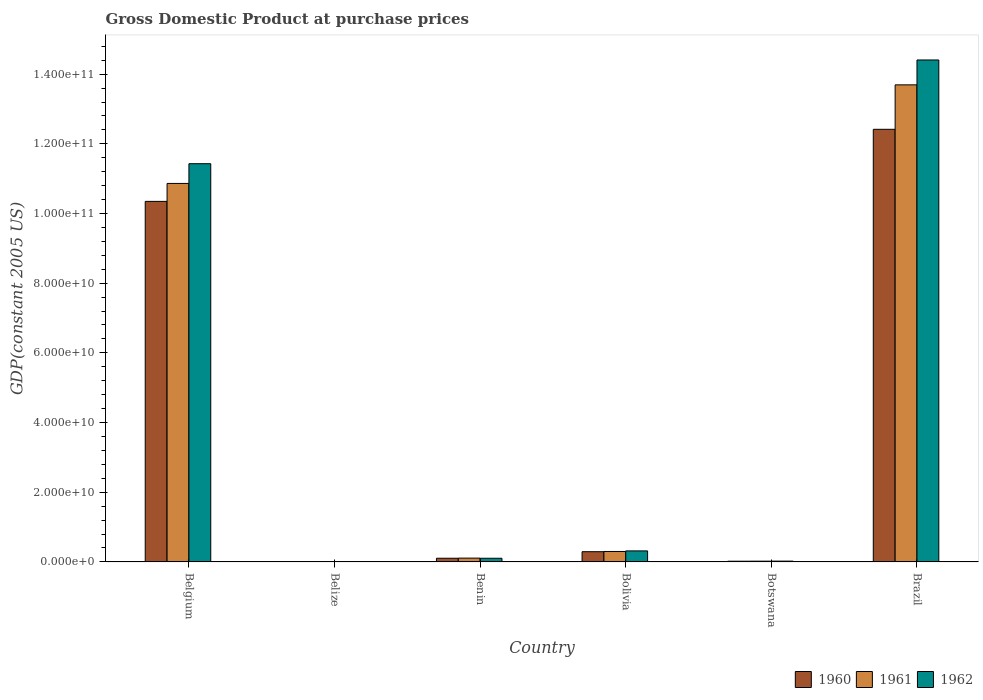How many groups of bars are there?
Keep it short and to the point. 6. How many bars are there on the 5th tick from the left?
Offer a terse response. 3. What is the GDP at purchase prices in 1962 in Botswana?
Ensure brevity in your answer.  2.26e+08. Across all countries, what is the maximum GDP at purchase prices in 1961?
Give a very brief answer. 1.37e+11. Across all countries, what is the minimum GDP at purchase prices in 1961?
Your answer should be very brief. 9.38e+07. In which country was the GDP at purchase prices in 1960 maximum?
Your answer should be compact. Brazil. In which country was the GDP at purchase prices in 1960 minimum?
Your answer should be compact. Belize. What is the total GDP at purchase prices in 1961 in the graph?
Keep it short and to the point. 2.50e+11. What is the difference between the GDP at purchase prices in 1961 in Botswana and that in Brazil?
Your response must be concise. -1.37e+11. What is the difference between the GDP at purchase prices in 1961 in Belgium and the GDP at purchase prices in 1960 in Botswana?
Your answer should be very brief. 1.08e+11. What is the average GDP at purchase prices in 1961 per country?
Your answer should be compact. 4.17e+1. What is the difference between the GDP at purchase prices of/in 1961 and GDP at purchase prices of/in 1960 in Belize?
Make the answer very short. 4.38e+06. What is the ratio of the GDP at purchase prices in 1961 in Belize to that in Botswana?
Give a very brief answer. 0.44. What is the difference between the highest and the second highest GDP at purchase prices in 1962?
Offer a very short reply. 1.11e+11. What is the difference between the highest and the lowest GDP at purchase prices in 1960?
Offer a very short reply. 1.24e+11. Is the sum of the GDP at purchase prices in 1960 in Botswana and Brazil greater than the maximum GDP at purchase prices in 1962 across all countries?
Your answer should be compact. No. What does the 3rd bar from the left in Brazil represents?
Ensure brevity in your answer.  1962. Are all the bars in the graph horizontal?
Give a very brief answer. No. What is the difference between two consecutive major ticks on the Y-axis?
Keep it short and to the point. 2.00e+1. What is the title of the graph?
Your answer should be very brief. Gross Domestic Product at purchase prices. What is the label or title of the X-axis?
Ensure brevity in your answer.  Country. What is the label or title of the Y-axis?
Your answer should be very brief. GDP(constant 2005 US). What is the GDP(constant 2005 US) of 1960 in Belgium?
Give a very brief answer. 1.03e+11. What is the GDP(constant 2005 US) of 1961 in Belgium?
Ensure brevity in your answer.  1.09e+11. What is the GDP(constant 2005 US) of 1962 in Belgium?
Offer a very short reply. 1.14e+11. What is the GDP(constant 2005 US) in 1960 in Belize?
Your answer should be very brief. 8.94e+07. What is the GDP(constant 2005 US) of 1961 in Belize?
Your answer should be compact. 9.38e+07. What is the GDP(constant 2005 US) in 1962 in Belize?
Your answer should be very brief. 9.84e+07. What is the GDP(constant 2005 US) in 1960 in Benin?
Provide a succinct answer. 1.05e+09. What is the GDP(constant 2005 US) of 1961 in Benin?
Your answer should be very brief. 1.09e+09. What is the GDP(constant 2005 US) of 1962 in Benin?
Offer a terse response. 1.05e+09. What is the GDP(constant 2005 US) of 1960 in Bolivia?
Make the answer very short. 2.93e+09. What is the GDP(constant 2005 US) in 1961 in Bolivia?
Give a very brief answer. 2.99e+09. What is the GDP(constant 2005 US) in 1962 in Bolivia?
Your answer should be compact. 3.16e+09. What is the GDP(constant 2005 US) in 1960 in Botswana?
Provide a short and direct response. 1.99e+08. What is the GDP(constant 2005 US) in 1961 in Botswana?
Make the answer very short. 2.12e+08. What is the GDP(constant 2005 US) of 1962 in Botswana?
Provide a succinct answer. 2.26e+08. What is the GDP(constant 2005 US) of 1960 in Brazil?
Make the answer very short. 1.24e+11. What is the GDP(constant 2005 US) in 1961 in Brazil?
Provide a succinct answer. 1.37e+11. What is the GDP(constant 2005 US) of 1962 in Brazil?
Offer a very short reply. 1.44e+11. Across all countries, what is the maximum GDP(constant 2005 US) of 1960?
Offer a terse response. 1.24e+11. Across all countries, what is the maximum GDP(constant 2005 US) in 1961?
Provide a short and direct response. 1.37e+11. Across all countries, what is the maximum GDP(constant 2005 US) of 1962?
Give a very brief answer. 1.44e+11. Across all countries, what is the minimum GDP(constant 2005 US) of 1960?
Your answer should be very brief. 8.94e+07. Across all countries, what is the minimum GDP(constant 2005 US) in 1961?
Offer a terse response. 9.38e+07. Across all countries, what is the minimum GDP(constant 2005 US) of 1962?
Your response must be concise. 9.84e+07. What is the total GDP(constant 2005 US) of 1960 in the graph?
Your response must be concise. 2.32e+11. What is the total GDP(constant 2005 US) in 1961 in the graph?
Ensure brevity in your answer.  2.50e+11. What is the total GDP(constant 2005 US) in 1962 in the graph?
Offer a terse response. 2.63e+11. What is the difference between the GDP(constant 2005 US) in 1960 in Belgium and that in Belize?
Keep it short and to the point. 1.03e+11. What is the difference between the GDP(constant 2005 US) of 1961 in Belgium and that in Belize?
Offer a very short reply. 1.09e+11. What is the difference between the GDP(constant 2005 US) in 1962 in Belgium and that in Belize?
Your answer should be compact. 1.14e+11. What is the difference between the GDP(constant 2005 US) in 1960 in Belgium and that in Benin?
Keep it short and to the point. 1.02e+11. What is the difference between the GDP(constant 2005 US) of 1961 in Belgium and that in Benin?
Provide a short and direct response. 1.08e+11. What is the difference between the GDP(constant 2005 US) in 1962 in Belgium and that in Benin?
Your answer should be very brief. 1.13e+11. What is the difference between the GDP(constant 2005 US) of 1960 in Belgium and that in Bolivia?
Ensure brevity in your answer.  1.01e+11. What is the difference between the GDP(constant 2005 US) of 1961 in Belgium and that in Bolivia?
Make the answer very short. 1.06e+11. What is the difference between the GDP(constant 2005 US) in 1962 in Belgium and that in Bolivia?
Ensure brevity in your answer.  1.11e+11. What is the difference between the GDP(constant 2005 US) of 1960 in Belgium and that in Botswana?
Offer a terse response. 1.03e+11. What is the difference between the GDP(constant 2005 US) in 1961 in Belgium and that in Botswana?
Ensure brevity in your answer.  1.08e+11. What is the difference between the GDP(constant 2005 US) in 1962 in Belgium and that in Botswana?
Ensure brevity in your answer.  1.14e+11. What is the difference between the GDP(constant 2005 US) in 1960 in Belgium and that in Brazil?
Your answer should be compact. -2.07e+1. What is the difference between the GDP(constant 2005 US) in 1961 in Belgium and that in Brazil?
Give a very brief answer. -2.83e+1. What is the difference between the GDP(constant 2005 US) in 1962 in Belgium and that in Brazil?
Offer a very short reply. -2.98e+1. What is the difference between the GDP(constant 2005 US) of 1960 in Belize and that in Benin?
Your answer should be compact. -9.64e+08. What is the difference between the GDP(constant 2005 US) in 1961 in Belize and that in Benin?
Provide a short and direct response. -9.92e+08. What is the difference between the GDP(constant 2005 US) of 1962 in Belize and that in Benin?
Ensure brevity in your answer.  -9.50e+08. What is the difference between the GDP(constant 2005 US) of 1960 in Belize and that in Bolivia?
Ensure brevity in your answer.  -2.84e+09. What is the difference between the GDP(constant 2005 US) of 1961 in Belize and that in Bolivia?
Your response must be concise. -2.90e+09. What is the difference between the GDP(constant 2005 US) in 1962 in Belize and that in Bolivia?
Your answer should be very brief. -3.06e+09. What is the difference between the GDP(constant 2005 US) in 1960 in Belize and that in Botswana?
Your response must be concise. -1.10e+08. What is the difference between the GDP(constant 2005 US) of 1961 in Belize and that in Botswana?
Give a very brief answer. -1.18e+08. What is the difference between the GDP(constant 2005 US) in 1962 in Belize and that in Botswana?
Keep it short and to the point. -1.27e+08. What is the difference between the GDP(constant 2005 US) in 1960 in Belize and that in Brazil?
Offer a very short reply. -1.24e+11. What is the difference between the GDP(constant 2005 US) in 1961 in Belize and that in Brazil?
Provide a succinct answer. -1.37e+11. What is the difference between the GDP(constant 2005 US) of 1962 in Belize and that in Brazil?
Your answer should be compact. -1.44e+11. What is the difference between the GDP(constant 2005 US) of 1960 in Benin and that in Bolivia?
Provide a succinct answer. -1.88e+09. What is the difference between the GDP(constant 2005 US) in 1961 in Benin and that in Bolivia?
Give a very brief answer. -1.91e+09. What is the difference between the GDP(constant 2005 US) in 1962 in Benin and that in Bolivia?
Keep it short and to the point. -2.11e+09. What is the difference between the GDP(constant 2005 US) in 1960 in Benin and that in Botswana?
Give a very brief answer. 8.54e+08. What is the difference between the GDP(constant 2005 US) of 1961 in Benin and that in Botswana?
Ensure brevity in your answer.  8.74e+08. What is the difference between the GDP(constant 2005 US) in 1962 in Benin and that in Botswana?
Offer a terse response. 8.23e+08. What is the difference between the GDP(constant 2005 US) of 1960 in Benin and that in Brazil?
Ensure brevity in your answer.  -1.23e+11. What is the difference between the GDP(constant 2005 US) in 1961 in Benin and that in Brazil?
Offer a very short reply. -1.36e+11. What is the difference between the GDP(constant 2005 US) of 1962 in Benin and that in Brazil?
Your response must be concise. -1.43e+11. What is the difference between the GDP(constant 2005 US) in 1960 in Bolivia and that in Botswana?
Your answer should be very brief. 2.73e+09. What is the difference between the GDP(constant 2005 US) of 1961 in Bolivia and that in Botswana?
Ensure brevity in your answer.  2.78e+09. What is the difference between the GDP(constant 2005 US) of 1962 in Bolivia and that in Botswana?
Provide a succinct answer. 2.93e+09. What is the difference between the GDP(constant 2005 US) of 1960 in Bolivia and that in Brazil?
Give a very brief answer. -1.21e+11. What is the difference between the GDP(constant 2005 US) in 1961 in Bolivia and that in Brazil?
Your answer should be compact. -1.34e+11. What is the difference between the GDP(constant 2005 US) of 1962 in Bolivia and that in Brazil?
Give a very brief answer. -1.41e+11. What is the difference between the GDP(constant 2005 US) of 1960 in Botswana and that in Brazil?
Offer a terse response. -1.24e+11. What is the difference between the GDP(constant 2005 US) of 1961 in Botswana and that in Brazil?
Your answer should be very brief. -1.37e+11. What is the difference between the GDP(constant 2005 US) in 1962 in Botswana and that in Brazil?
Give a very brief answer. -1.44e+11. What is the difference between the GDP(constant 2005 US) in 1960 in Belgium and the GDP(constant 2005 US) in 1961 in Belize?
Keep it short and to the point. 1.03e+11. What is the difference between the GDP(constant 2005 US) in 1960 in Belgium and the GDP(constant 2005 US) in 1962 in Belize?
Provide a succinct answer. 1.03e+11. What is the difference between the GDP(constant 2005 US) of 1961 in Belgium and the GDP(constant 2005 US) of 1962 in Belize?
Keep it short and to the point. 1.09e+11. What is the difference between the GDP(constant 2005 US) of 1960 in Belgium and the GDP(constant 2005 US) of 1961 in Benin?
Give a very brief answer. 1.02e+11. What is the difference between the GDP(constant 2005 US) of 1960 in Belgium and the GDP(constant 2005 US) of 1962 in Benin?
Your answer should be very brief. 1.02e+11. What is the difference between the GDP(constant 2005 US) in 1961 in Belgium and the GDP(constant 2005 US) in 1962 in Benin?
Your answer should be very brief. 1.08e+11. What is the difference between the GDP(constant 2005 US) in 1960 in Belgium and the GDP(constant 2005 US) in 1961 in Bolivia?
Offer a very short reply. 1.00e+11. What is the difference between the GDP(constant 2005 US) in 1960 in Belgium and the GDP(constant 2005 US) in 1962 in Bolivia?
Make the answer very short. 1.00e+11. What is the difference between the GDP(constant 2005 US) in 1961 in Belgium and the GDP(constant 2005 US) in 1962 in Bolivia?
Give a very brief answer. 1.05e+11. What is the difference between the GDP(constant 2005 US) in 1960 in Belgium and the GDP(constant 2005 US) in 1961 in Botswana?
Offer a terse response. 1.03e+11. What is the difference between the GDP(constant 2005 US) in 1960 in Belgium and the GDP(constant 2005 US) in 1962 in Botswana?
Ensure brevity in your answer.  1.03e+11. What is the difference between the GDP(constant 2005 US) in 1961 in Belgium and the GDP(constant 2005 US) in 1962 in Botswana?
Provide a succinct answer. 1.08e+11. What is the difference between the GDP(constant 2005 US) of 1960 in Belgium and the GDP(constant 2005 US) of 1961 in Brazil?
Your answer should be very brief. -3.34e+1. What is the difference between the GDP(constant 2005 US) in 1960 in Belgium and the GDP(constant 2005 US) in 1962 in Brazil?
Offer a terse response. -4.06e+1. What is the difference between the GDP(constant 2005 US) in 1961 in Belgium and the GDP(constant 2005 US) in 1962 in Brazil?
Your answer should be compact. -3.54e+1. What is the difference between the GDP(constant 2005 US) of 1960 in Belize and the GDP(constant 2005 US) of 1961 in Benin?
Your response must be concise. -9.97e+08. What is the difference between the GDP(constant 2005 US) in 1960 in Belize and the GDP(constant 2005 US) in 1962 in Benin?
Ensure brevity in your answer.  -9.59e+08. What is the difference between the GDP(constant 2005 US) of 1961 in Belize and the GDP(constant 2005 US) of 1962 in Benin?
Make the answer very short. -9.55e+08. What is the difference between the GDP(constant 2005 US) in 1960 in Belize and the GDP(constant 2005 US) in 1961 in Bolivia?
Provide a succinct answer. -2.90e+09. What is the difference between the GDP(constant 2005 US) of 1960 in Belize and the GDP(constant 2005 US) of 1962 in Bolivia?
Provide a short and direct response. -3.07e+09. What is the difference between the GDP(constant 2005 US) in 1961 in Belize and the GDP(constant 2005 US) in 1962 in Bolivia?
Make the answer very short. -3.07e+09. What is the difference between the GDP(constant 2005 US) in 1960 in Belize and the GDP(constant 2005 US) in 1961 in Botswana?
Provide a succinct answer. -1.22e+08. What is the difference between the GDP(constant 2005 US) of 1960 in Belize and the GDP(constant 2005 US) of 1962 in Botswana?
Your response must be concise. -1.36e+08. What is the difference between the GDP(constant 2005 US) of 1961 in Belize and the GDP(constant 2005 US) of 1962 in Botswana?
Your answer should be very brief. -1.32e+08. What is the difference between the GDP(constant 2005 US) of 1960 in Belize and the GDP(constant 2005 US) of 1961 in Brazil?
Provide a short and direct response. -1.37e+11. What is the difference between the GDP(constant 2005 US) of 1960 in Belize and the GDP(constant 2005 US) of 1962 in Brazil?
Provide a succinct answer. -1.44e+11. What is the difference between the GDP(constant 2005 US) of 1961 in Belize and the GDP(constant 2005 US) of 1962 in Brazil?
Your answer should be very brief. -1.44e+11. What is the difference between the GDP(constant 2005 US) of 1960 in Benin and the GDP(constant 2005 US) of 1961 in Bolivia?
Offer a very short reply. -1.94e+09. What is the difference between the GDP(constant 2005 US) in 1960 in Benin and the GDP(constant 2005 US) in 1962 in Bolivia?
Keep it short and to the point. -2.11e+09. What is the difference between the GDP(constant 2005 US) of 1961 in Benin and the GDP(constant 2005 US) of 1962 in Bolivia?
Provide a short and direct response. -2.07e+09. What is the difference between the GDP(constant 2005 US) of 1960 in Benin and the GDP(constant 2005 US) of 1961 in Botswana?
Keep it short and to the point. 8.41e+08. What is the difference between the GDP(constant 2005 US) of 1960 in Benin and the GDP(constant 2005 US) of 1962 in Botswana?
Make the answer very short. 8.27e+08. What is the difference between the GDP(constant 2005 US) in 1961 in Benin and the GDP(constant 2005 US) in 1962 in Botswana?
Give a very brief answer. 8.60e+08. What is the difference between the GDP(constant 2005 US) in 1960 in Benin and the GDP(constant 2005 US) in 1961 in Brazil?
Keep it short and to the point. -1.36e+11. What is the difference between the GDP(constant 2005 US) in 1960 in Benin and the GDP(constant 2005 US) in 1962 in Brazil?
Ensure brevity in your answer.  -1.43e+11. What is the difference between the GDP(constant 2005 US) of 1961 in Benin and the GDP(constant 2005 US) of 1962 in Brazil?
Provide a short and direct response. -1.43e+11. What is the difference between the GDP(constant 2005 US) in 1960 in Bolivia and the GDP(constant 2005 US) in 1961 in Botswana?
Your answer should be compact. 2.72e+09. What is the difference between the GDP(constant 2005 US) of 1960 in Bolivia and the GDP(constant 2005 US) of 1962 in Botswana?
Ensure brevity in your answer.  2.71e+09. What is the difference between the GDP(constant 2005 US) in 1961 in Bolivia and the GDP(constant 2005 US) in 1962 in Botswana?
Ensure brevity in your answer.  2.77e+09. What is the difference between the GDP(constant 2005 US) in 1960 in Bolivia and the GDP(constant 2005 US) in 1961 in Brazil?
Make the answer very short. -1.34e+11. What is the difference between the GDP(constant 2005 US) of 1960 in Bolivia and the GDP(constant 2005 US) of 1962 in Brazil?
Ensure brevity in your answer.  -1.41e+11. What is the difference between the GDP(constant 2005 US) in 1961 in Bolivia and the GDP(constant 2005 US) in 1962 in Brazil?
Your response must be concise. -1.41e+11. What is the difference between the GDP(constant 2005 US) of 1960 in Botswana and the GDP(constant 2005 US) of 1961 in Brazil?
Offer a very short reply. -1.37e+11. What is the difference between the GDP(constant 2005 US) in 1960 in Botswana and the GDP(constant 2005 US) in 1962 in Brazil?
Offer a very short reply. -1.44e+11. What is the difference between the GDP(constant 2005 US) in 1961 in Botswana and the GDP(constant 2005 US) in 1962 in Brazil?
Make the answer very short. -1.44e+11. What is the average GDP(constant 2005 US) of 1960 per country?
Provide a succinct answer. 3.87e+1. What is the average GDP(constant 2005 US) of 1961 per country?
Provide a short and direct response. 4.17e+1. What is the average GDP(constant 2005 US) of 1962 per country?
Provide a short and direct response. 4.38e+1. What is the difference between the GDP(constant 2005 US) of 1960 and GDP(constant 2005 US) of 1961 in Belgium?
Give a very brief answer. -5.15e+09. What is the difference between the GDP(constant 2005 US) in 1960 and GDP(constant 2005 US) in 1962 in Belgium?
Give a very brief answer. -1.08e+1. What is the difference between the GDP(constant 2005 US) of 1961 and GDP(constant 2005 US) of 1962 in Belgium?
Offer a very short reply. -5.66e+09. What is the difference between the GDP(constant 2005 US) of 1960 and GDP(constant 2005 US) of 1961 in Belize?
Give a very brief answer. -4.38e+06. What is the difference between the GDP(constant 2005 US) of 1960 and GDP(constant 2005 US) of 1962 in Belize?
Offer a very short reply. -8.97e+06. What is the difference between the GDP(constant 2005 US) of 1961 and GDP(constant 2005 US) of 1962 in Belize?
Your response must be concise. -4.59e+06. What is the difference between the GDP(constant 2005 US) of 1960 and GDP(constant 2005 US) of 1961 in Benin?
Give a very brief answer. -3.31e+07. What is the difference between the GDP(constant 2005 US) in 1960 and GDP(constant 2005 US) in 1962 in Benin?
Offer a terse response. 4.14e+06. What is the difference between the GDP(constant 2005 US) of 1961 and GDP(constant 2005 US) of 1962 in Benin?
Offer a terse response. 3.72e+07. What is the difference between the GDP(constant 2005 US) in 1960 and GDP(constant 2005 US) in 1961 in Bolivia?
Offer a very short reply. -6.10e+07. What is the difference between the GDP(constant 2005 US) in 1960 and GDP(constant 2005 US) in 1962 in Bolivia?
Make the answer very short. -2.28e+08. What is the difference between the GDP(constant 2005 US) in 1961 and GDP(constant 2005 US) in 1962 in Bolivia?
Provide a succinct answer. -1.67e+08. What is the difference between the GDP(constant 2005 US) in 1960 and GDP(constant 2005 US) in 1961 in Botswana?
Keep it short and to the point. -1.26e+07. What is the difference between the GDP(constant 2005 US) in 1960 and GDP(constant 2005 US) in 1962 in Botswana?
Your response must be concise. -2.67e+07. What is the difference between the GDP(constant 2005 US) in 1961 and GDP(constant 2005 US) in 1962 in Botswana?
Your answer should be very brief. -1.41e+07. What is the difference between the GDP(constant 2005 US) of 1960 and GDP(constant 2005 US) of 1961 in Brazil?
Give a very brief answer. -1.28e+1. What is the difference between the GDP(constant 2005 US) in 1960 and GDP(constant 2005 US) in 1962 in Brazil?
Keep it short and to the point. -1.99e+1. What is the difference between the GDP(constant 2005 US) in 1961 and GDP(constant 2005 US) in 1962 in Brazil?
Your answer should be compact. -7.14e+09. What is the ratio of the GDP(constant 2005 US) in 1960 in Belgium to that in Belize?
Offer a very short reply. 1156.97. What is the ratio of the GDP(constant 2005 US) in 1961 in Belgium to that in Belize?
Your answer should be very brief. 1157.92. What is the ratio of the GDP(constant 2005 US) in 1962 in Belgium to that in Belize?
Offer a very short reply. 1161.44. What is the ratio of the GDP(constant 2005 US) in 1960 in Belgium to that in Benin?
Make the answer very short. 98.27. What is the ratio of the GDP(constant 2005 US) of 1961 in Belgium to that in Benin?
Provide a short and direct response. 100.02. What is the ratio of the GDP(constant 2005 US) of 1962 in Belgium to that in Benin?
Your response must be concise. 108.97. What is the ratio of the GDP(constant 2005 US) of 1960 in Belgium to that in Bolivia?
Make the answer very short. 35.3. What is the ratio of the GDP(constant 2005 US) in 1961 in Belgium to that in Bolivia?
Offer a terse response. 36.3. What is the ratio of the GDP(constant 2005 US) in 1962 in Belgium to that in Bolivia?
Your response must be concise. 36.18. What is the ratio of the GDP(constant 2005 US) of 1960 in Belgium to that in Botswana?
Your answer should be compact. 519.98. What is the ratio of the GDP(constant 2005 US) of 1961 in Belgium to that in Botswana?
Your answer should be very brief. 513.31. What is the ratio of the GDP(constant 2005 US) of 1962 in Belgium to that in Botswana?
Your answer should be very brief. 506.31. What is the ratio of the GDP(constant 2005 US) of 1960 in Belgium to that in Brazil?
Keep it short and to the point. 0.83. What is the ratio of the GDP(constant 2005 US) of 1961 in Belgium to that in Brazil?
Your answer should be compact. 0.79. What is the ratio of the GDP(constant 2005 US) in 1962 in Belgium to that in Brazil?
Offer a terse response. 0.79. What is the ratio of the GDP(constant 2005 US) of 1960 in Belize to that in Benin?
Offer a terse response. 0.08. What is the ratio of the GDP(constant 2005 US) of 1961 in Belize to that in Benin?
Give a very brief answer. 0.09. What is the ratio of the GDP(constant 2005 US) in 1962 in Belize to that in Benin?
Give a very brief answer. 0.09. What is the ratio of the GDP(constant 2005 US) of 1960 in Belize to that in Bolivia?
Offer a terse response. 0.03. What is the ratio of the GDP(constant 2005 US) of 1961 in Belize to that in Bolivia?
Keep it short and to the point. 0.03. What is the ratio of the GDP(constant 2005 US) in 1962 in Belize to that in Bolivia?
Keep it short and to the point. 0.03. What is the ratio of the GDP(constant 2005 US) in 1960 in Belize to that in Botswana?
Give a very brief answer. 0.45. What is the ratio of the GDP(constant 2005 US) in 1961 in Belize to that in Botswana?
Give a very brief answer. 0.44. What is the ratio of the GDP(constant 2005 US) of 1962 in Belize to that in Botswana?
Ensure brevity in your answer.  0.44. What is the ratio of the GDP(constant 2005 US) in 1960 in Belize to that in Brazil?
Keep it short and to the point. 0. What is the ratio of the GDP(constant 2005 US) of 1961 in Belize to that in Brazil?
Your answer should be compact. 0. What is the ratio of the GDP(constant 2005 US) of 1962 in Belize to that in Brazil?
Offer a very short reply. 0. What is the ratio of the GDP(constant 2005 US) in 1960 in Benin to that in Bolivia?
Ensure brevity in your answer.  0.36. What is the ratio of the GDP(constant 2005 US) in 1961 in Benin to that in Bolivia?
Keep it short and to the point. 0.36. What is the ratio of the GDP(constant 2005 US) in 1962 in Benin to that in Bolivia?
Keep it short and to the point. 0.33. What is the ratio of the GDP(constant 2005 US) in 1960 in Benin to that in Botswana?
Offer a terse response. 5.29. What is the ratio of the GDP(constant 2005 US) of 1961 in Benin to that in Botswana?
Keep it short and to the point. 5.13. What is the ratio of the GDP(constant 2005 US) of 1962 in Benin to that in Botswana?
Your answer should be compact. 4.65. What is the ratio of the GDP(constant 2005 US) in 1960 in Benin to that in Brazil?
Provide a short and direct response. 0.01. What is the ratio of the GDP(constant 2005 US) in 1961 in Benin to that in Brazil?
Offer a terse response. 0.01. What is the ratio of the GDP(constant 2005 US) in 1962 in Benin to that in Brazil?
Give a very brief answer. 0.01. What is the ratio of the GDP(constant 2005 US) of 1960 in Bolivia to that in Botswana?
Offer a terse response. 14.73. What is the ratio of the GDP(constant 2005 US) in 1961 in Bolivia to that in Botswana?
Keep it short and to the point. 14.14. What is the ratio of the GDP(constant 2005 US) of 1962 in Bolivia to that in Botswana?
Give a very brief answer. 14. What is the ratio of the GDP(constant 2005 US) in 1960 in Bolivia to that in Brazil?
Make the answer very short. 0.02. What is the ratio of the GDP(constant 2005 US) in 1961 in Bolivia to that in Brazil?
Make the answer very short. 0.02. What is the ratio of the GDP(constant 2005 US) of 1962 in Bolivia to that in Brazil?
Make the answer very short. 0.02. What is the ratio of the GDP(constant 2005 US) of 1960 in Botswana to that in Brazil?
Provide a succinct answer. 0. What is the ratio of the GDP(constant 2005 US) in 1961 in Botswana to that in Brazil?
Offer a terse response. 0. What is the ratio of the GDP(constant 2005 US) in 1962 in Botswana to that in Brazil?
Provide a succinct answer. 0. What is the difference between the highest and the second highest GDP(constant 2005 US) in 1960?
Your response must be concise. 2.07e+1. What is the difference between the highest and the second highest GDP(constant 2005 US) of 1961?
Your answer should be compact. 2.83e+1. What is the difference between the highest and the second highest GDP(constant 2005 US) of 1962?
Keep it short and to the point. 2.98e+1. What is the difference between the highest and the lowest GDP(constant 2005 US) of 1960?
Provide a short and direct response. 1.24e+11. What is the difference between the highest and the lowest GDP(constant 2005 US) of 1961?
Your response must be concise. 1.37e+11. What is the difference between the highest and the lowest GDP(constant 2005 US) in 1962?
Provide a succinct answer. 1.44e+11. 